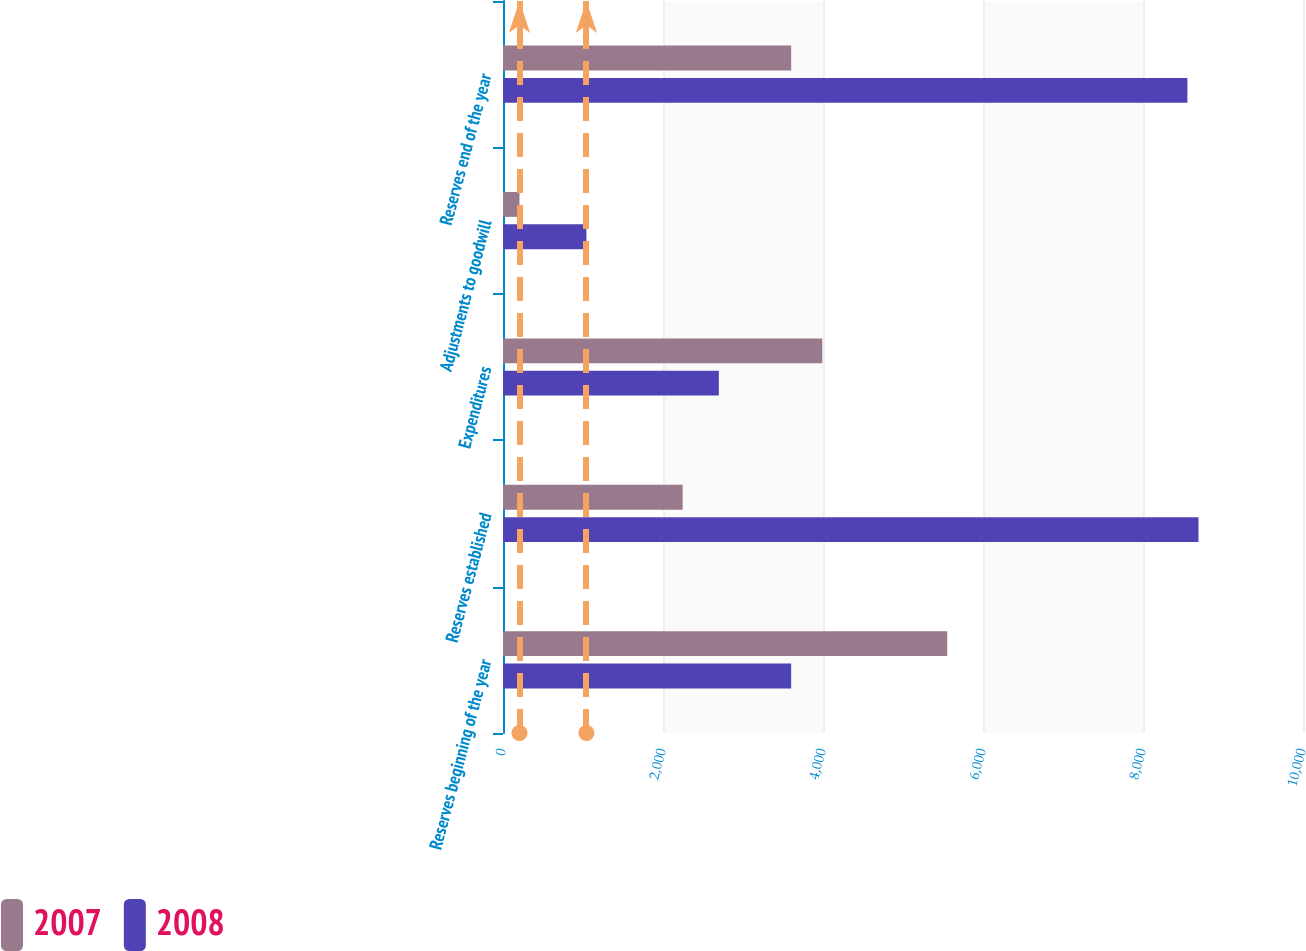Convert chart. <chart><loc_0><loc_0><loc_500><loc_500><stacked_bar_chart><ecel><fcel>Reserves beginning of the year<fcel>Reserves established<fcel>Expenditures<fcel>Adjustments to goodwill<fcel>Reserves end of the year<nl><fcel>2007<fcel>5553<fcel>2246<fcel>3991<fcel>206<fcel>3602<nl><fcel>2008<fcel>3602<fcel>8694<fcel>2698<fcel>1043<fcel>8555<nl></chart> 